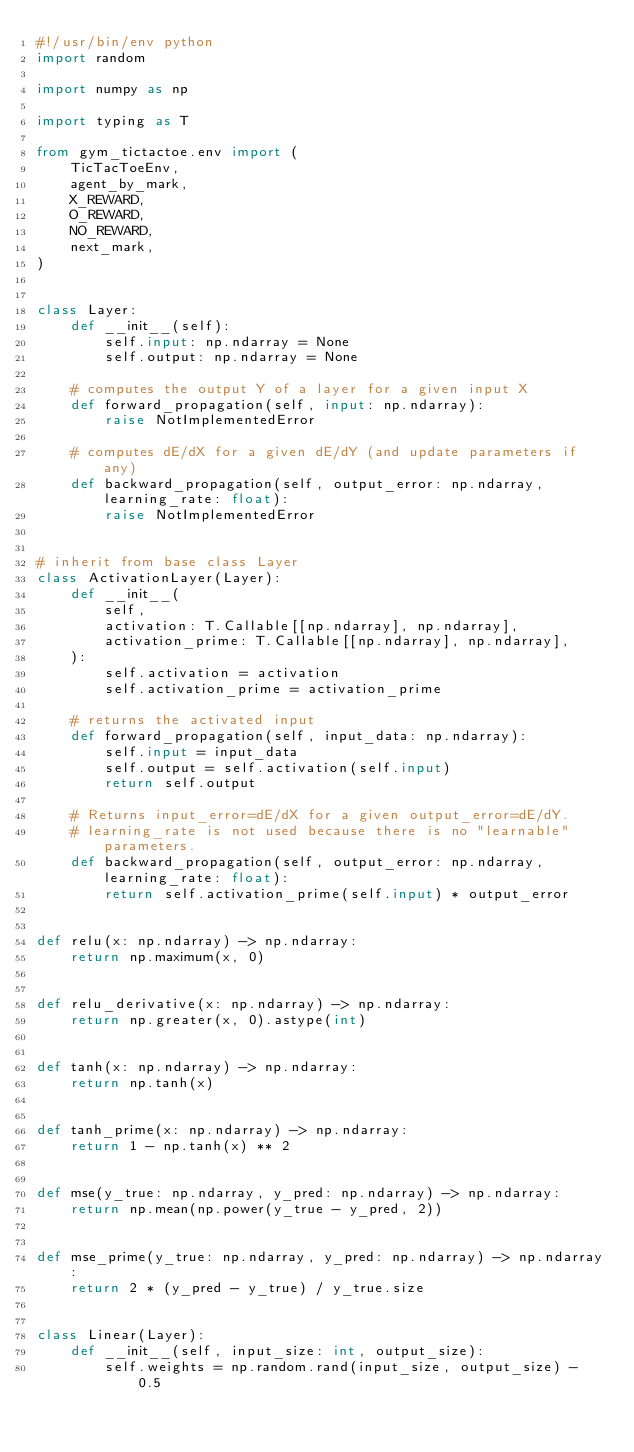<code> <loc_0><loc_0><loc_500><loc_500><_Python_>#!/usr/bin/env python
import random

import numpy as np

import typing as T

from gym_tictactoe.env import (
    TicTacToeEnv,
    agent_by_mark,
    X_REWARD,
    O_REWARD,
    NO_REWARD,
    next_mark,
)


class Layer:
    def __init__(self):
        self.input: np.ndarray = None
        self.output: np.ndarray = None

    # computes the output Y of a layer for a given input X
    def forward_propagation(self, input: np.ndarray):
        raise NotImplementedError

    # computes dE/dX for a given dE/dY (and update parameters if any)
    def backward_propagation(self, output_error: np.ndarray, learning_rate: float):
        raise NotImplementedError


# inherit from base class Layer
class ActivationLayer(Layer):
    def __init__(
        self,
        activation: T.Callable[[np.ndarray], np.ndarray],
        activation_prime: T.Callable[[np.ndarray], np.ndarray],
    ):
        self.activation = activation
        self.activation_prime = activation_prime

    # returns the activated input
    def forward_propagation(self, input_data: np.ndarray):
        self.input = input_data
        self.output = self.activation(self.input)
        return self.output

    # Returns input_error=dE/dX for a given output_error=dE/dY.
    # learning_rate is not used because there is no "learnable" parameters.
    def backward_propagation(self, output_error: np.ndarray, learning_rate: float):
        return self.activation_prime(self.input) * output_error


def relu(x: np.ndarray) -> np.ndarray:
    return np.maximum(x, 0)


def relu_derivative(x: np.ndarray) -> np.ndarray:
    return np.greater(x, 0).astype(int)


def tanh(x: np.ndarray) -> np.ndarray:
    return np.tanh(x)


def tanh_prime(x: np.ndarray) -> np.ndarray:
    return 1 - np.tanh(x) ** 2


def mse(y_true: np.ndarray, y_pred: np.ndarray) -> np.ndarray:
    return np.mean(np.power(y_true - y_pred, 2))


def mse_prime(y_true: np.ndarray, y_pred: np.ndarray) -> np.ndarray:
    return 2 * (y_pred - y_true) / y_true.size


class Linear(Layer):
    def __init__(self, input_size: int, output_size):
        self.weights = np.random.rand(input_size, output_size) - 0.5</code> 